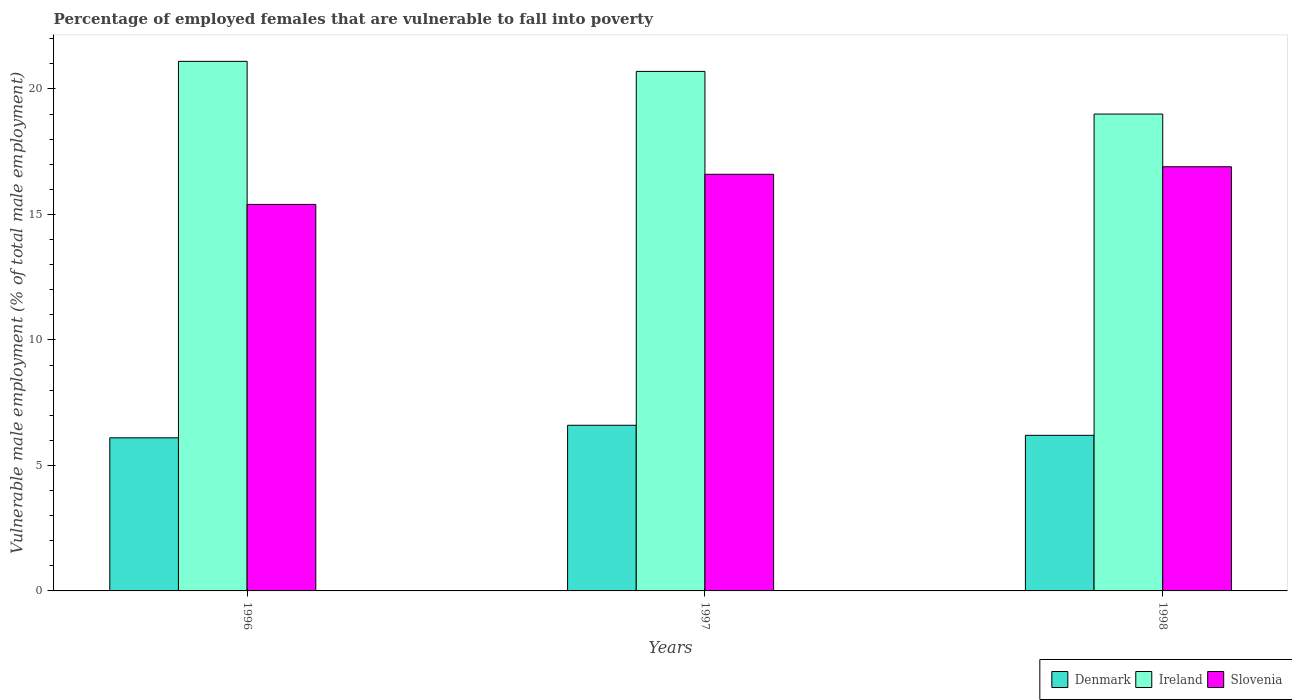How many different coloured bars are there?
Provide a short and direct response. 3. How many groups of bars are there?
Your answer should be very brief. 3. What is the label of the 2nd group of bars from the left?
Offer a very short reply. 1997. In how many cases, is the number of bars for a given year not equal to the number of legend labels?
Your answer should be very brief. 0. What is the percentage of employed females who are vulnerable to fall into poverty in Slovenia in 1996?
Ensure brevity in your answer.  15.4. Across all years, what is the maximum percentage of employed females who are vulnerable to fall into poverty in Slovenia?
Offer a terse response. 16.9. Across all years, what is the minimum percentage of employed females who are vulnerable to fall into poverty in Denmark?
Your answer should be compact. 6.1. In which year was the percentage of employed females who are vulnerable to fall into poverty in Slovenia maximum?
Your answer should be compact. 1998. In which year was the percentage of employed females who are vulnerable to fall into poverty in Denmark minimum?
Your response must be concise. 1996. What is the total percentage of employed females who are vulnerable to fall into poverty in Denmark in the graph?
Your response must be concise. 18.9. What is the difference between the percentage of employed females who are vulnerable to fall into poverty in Ireland in 1997 and that in 1998?
Your answer should be compact. 1.7. What is the difference between the percentage of employed females who are vulnerable to fall into poverty in Ireland in 1997 and the percentage of employed females who are vulnerable to fall into poverty in Denmark in 1998?
Offer a very short reply. 14.5. What is the average percentage of employed females who are vulnerable to fall into poverty in Slovenia per year?
Give a very brief answer. 16.3. In the year 1996, what is the difference between the percentage of employed females who are vulnerable to fall into poverty in Denmark and percentage of employed females who are vulnerable to fall into poverty in Ireland?
Provide a succinct answer. -15. What is the ratio of the percentage of employed females who are vulnerable to fall into poverty in Ireland in 1997 to that in 1998?
Provide a short and direct response. 1.09. Is the percentage of employed females who are vulnerable to fall into poverty in Ireland in 1996 less than that in 1997?
Give a very brief answer. No. What is the difference between the highest and the second highest percentage of employed females who are vulnerable to fall into poverty in Denmark?
Provide a short and direct response. 0.4. What is the difference between the highest and the lowest percentage of employed females who are vulnerable to fall into poverty in Ireland?
Make the answer very short. 2.1. Is the sum of the percentage of employed females who are vulnerable to fall into poverty in Ireland in 1996 and 1997 greater than the maximum percentage of employed females who are vulnerable to fall into poverty in Denmark across all years?
Your answer should be compact. Yes. What does the 1st bar from the left in 1997 represents?
Make the answer very short. Denmark. What does the 2nd bar from the right in 1998 represents?
Offer a terse response. Ireland. How many bars are there?
Offer a terse response. 9. Are all the bars in the graph horizontal?
Provide a succinct answer. No. Does the graph contain any zero values?
Your answer should be very brief. No. How are the legend labels stacked?
Make the answer very short. Horizontal. What is the title of the graph?
Give a very brief answer. Percentage of employed females that are vulnerable to fall into poverty. What is the label or title of the Y-axis?
Your answer should be compact. Vulnerable male employment (% of total male employment). What is the Vulnerable male employment (% of total male employment) in Denmark in 1996?
Your answer should be compact. 6.1. What is the Vulnerable male employment (% of total male employment) of Ireland in 1996?
Make the answer very short. 21.1. What is the Vulnerable male employment (% of total male employment) of Slovenia in 1996?
Provide a short and direct response. 15.4. What is the Vulnerable male employment (% of total male employment) of Denmark in 1997?
Your answer should be very brief. 6.6. What is the Vulnerable male employment (% of total male employment) in Ireland in 1997?
Your answer should be compact. 20.7. What is the Vulnerable male employment (% of total male employment) in Slovenia in 1997?
Provide a succinct answer. 16.6. What is the Vulnerable male employment (% of total male employment) in Denmark in 1998?
Your answer should be very brief. 6.2. What is the Vulnerable male employment (% of total male employment) in Ireland in 1998?
Your answer should be compact. 19. What is the Vulnerable male employment (% of total male employment) in Slovenia in 1998?
Offer a terse response. 16.9. Across all years, what is the maximum Vulnerable male employment (% of total male employment) of Denmark?
Provide a succinct answer. 6.6. Across all years, what is the maximum Vulnerable male employment (% of total male employment) of Ireland?
Your answer should be compact. 21.1. Across all years, what is the maximum Vulnerable male employment (% of total male employment) in Slovenia?
Provide a succinct answer. 16.9. Across all years, what is the minimum Vulnerable male employment (% of total male employment) of Denmark?
Give a very brief answer. 6.1. Across all years, what is the minimum Vulnerable male employment (% of total male employment) in Ireland?
Your answer should be compact. 19. Across all years, what is the minimum Vulnerable male employment (% of total male employment) in Slovenia?
Provide a short and direct response. 15.4. What is the total Vulnerable male employment (% of total male employment) in Ireland in the graph?
Provide a short and direct response. 60.8. What is the total Vulnerable male employment (% of total male employment) of Slovenia in the graph?
Provide a short and direct response. 48.9. What is the difference between the Vulnerable male employment (% of total male employment) of Denmark in 1996 and that in 1998?
Your answer should be compact. -0.1. What is the difference between the Vulnerable male employment (% of total male employment) in Ireland in 1996 and that in 1998?
Offer a terse response. 2.1. What is the difference between the Vulnerable male employment (% of total male employment) of Slovenia in 1996 and that in 1998?
Offer a very short reply. -1.5. What is the difference between the Vulnerable male employment (% of total male employment) of Denmark in 1997 and that in 1998?
Make the answer very short. 0.4. What is the difference between the Vulnerable male employment (% of total male employment) in Ireland in 1997 and that in 1998?
Keep it short and to the point. 1.7. What is the difference between the Vulnerable male employment (% of total male employment) of Slovenia in 1997 and that in 1998?
Ensure brevity in your answer.  -0.3. What is the difference between the Vulnerable male employment (% of total male employment) of Denmark in 1996 and the Vulnerable male employment (% of total male employment) of Ireland in 1997?
Your response must be concise. -14.6. What is the difference between the Vulnerable male employment (% of total male employment) in Denmark in 1996 and the Vulnerable male employment (% of total male employment) in Slovenia in 1997?
Offer a terse response. -10.5. What is the difference between the Vulnerable male employment (% of total male employment) in Ireland in 1996 and the Vulnerable male employment (% of total male employment) in Slovenia in 1997?
Give a very brief answer. 4.5. What is the difference between the Vulnerable male employment (% of total male employment) in Denmark in 1996 and the Vulnerable male employment (% of total male employment) in Slovenia in 1998?
Provide a short and direct response. -10.8. What is the difference between the Vulnerable male employment (% of total male employment) of Ireland in 1996 and the Vulnerable male employment (% of total male employment) of Slovenia in 1998?
Keep it short and to the point. 4.2. What is the difference between the Vulnerable male employment (% of total male employment) in Denmark in 1997 and the Vulnerable male employment (% of total male employment) in Ireland in 1998?
Your response must be concise. -12.4. What is the average Vulnerable male employment (% of total male employment) of Denmark per year?
Offer a very short reply. 6.3. What is the average Vulnerable male employment (% of total male employment) of Ireland per year?
Provide a short and direct response. 20.27. What is the average Vulnerable male employment (% of total male employment) of Slovenia per year?
Offer a terse response. 16.3. In the year 1997, what is the difference between the Vulnerable male employment (% of total male employment) of Denmark and Vulnerable male employment (% of total male employment) of Ireland?
Make the answer very short. -14.1. In the year 1997, what is the difference between the Vulnerable male employment (% of total male employment) of Ireland and Vulnerable male employment (% of total male employment) of Slovenia?
Offer a terse response. 4.1. In the year 1998, what is the difference between the Vulnerable male employment (% of total male employment) in Denmark and Vulnerable male employment (% of total male employment) in Ireland?
Your answer should be compact. -12.8. In the year 1998, what is the difference between the Vulnerable male employment (% of total male employment) in Denmark and Vulnerable male employment (% of total male employment) in Slovenia?
Ensure brevity in your answer.  -10.7. In the year 1998, what is the difference between the Vulnerable male employment (% of total male employment) of Ireland and Vulnerable male employment (% of total male employment) of Slovenia?
Offer a very short reply. 2.1. What is the ratio of the Vulnerable male employment (% of total male employment) of Denmark in 1996 to that in 1997?
Your answer should be very brief. 0.92. What is the ratio of the Vulnerable male employment (% of total male employment) of Ireland in 1996 to that in 1997?
Make the answer very short. 1.02. What is the ratio of the Vulnerable male employment (% of total male employment) in Slovenia in 1996 to that in 1997?
Your answer should be very brief. 0.93. What is the ratio of the Vulnerable male employment (% of total male employment) of Denmark in 1996 to that in 1998?
Provide a short and direct response. 0.98. What is the ratio of the Vulnerable male employment (% of total male employment) in Ireland in 1996 to that in 1998?
Offer a very short reply. 1.11. What is the ratio of the Vulnerable male employment (% of total male employment) in Slovenia in 1996 to that in 1998?
Keep it short and to the point. 0.91. What is the ratio of the Vulnerable male employment (% of total male employment) in Denmark in 1997 to that in 1998?
Offer a terse response. 1.06. What is the ratio of the Vulnerable male employment (% of total male employment) of Ireland in 1997 to that in 1998?
Offer a very short reply. 1.09. What is the ratio of the Vulnerable male employment (% of total male employment) of Slovenia in 1997 to that in 1998?
Make the answer very short. 0.98. What is the difference between the highest and the second highest Vulnerable male employment (% of total male employment) of Slovenia?
Make the answer very short. 0.3. What is the difference between the highest and the lowest Vulnerable male employment (% of total male employment) of Ireland?
Offer a very short reply. 2.1. What is the difference between the highest and the lowest Vulnerable male employment (% of total male employment) in Slovenia?
Keep it short and to the point. 1.5. 